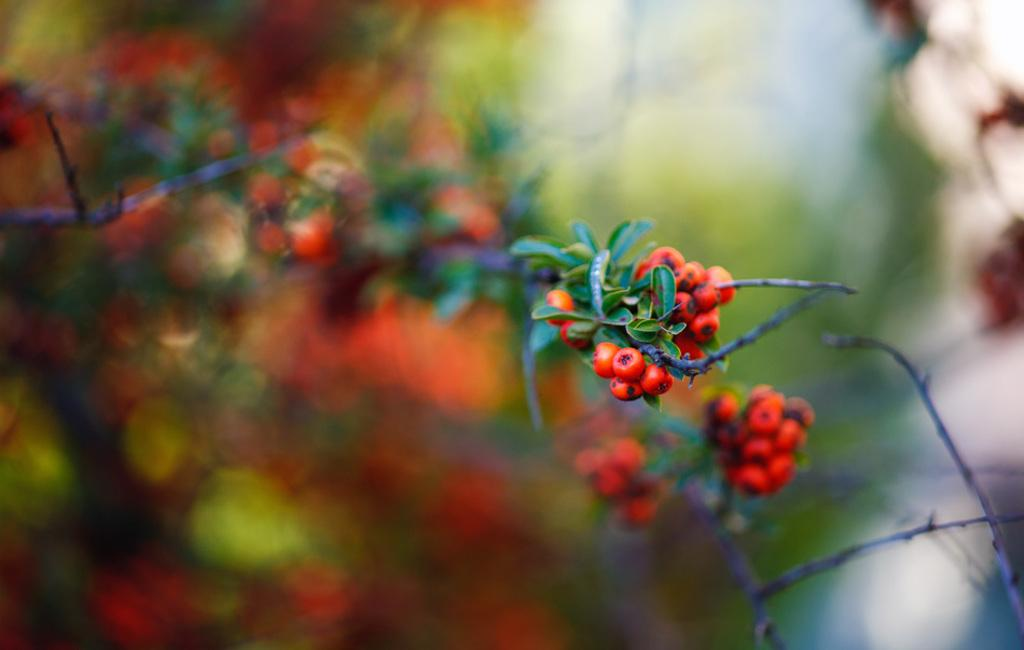What type of living organism can be seen in the image? There is a plant in the image. What are the small, round objects in the image? There are berries in the image. What type of fear can be seen in the image? There is no fear present in the image; it features a plant and berries. What type of stone is visible in the image? There is no stone present in the image. 